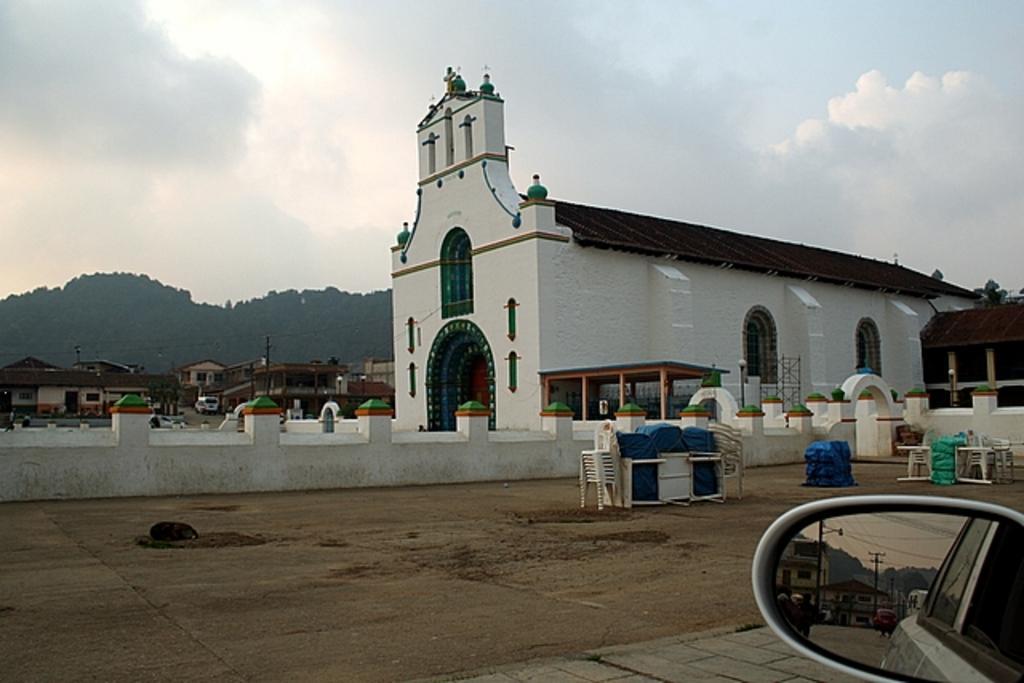Could you give a brief overview of what you see in this image? In the center of the image there is a building. On the right side of the image we can see chairs and a car mirror. On the left side there are buildings and vehicles. In the background there is a sky, hills and clouds. 